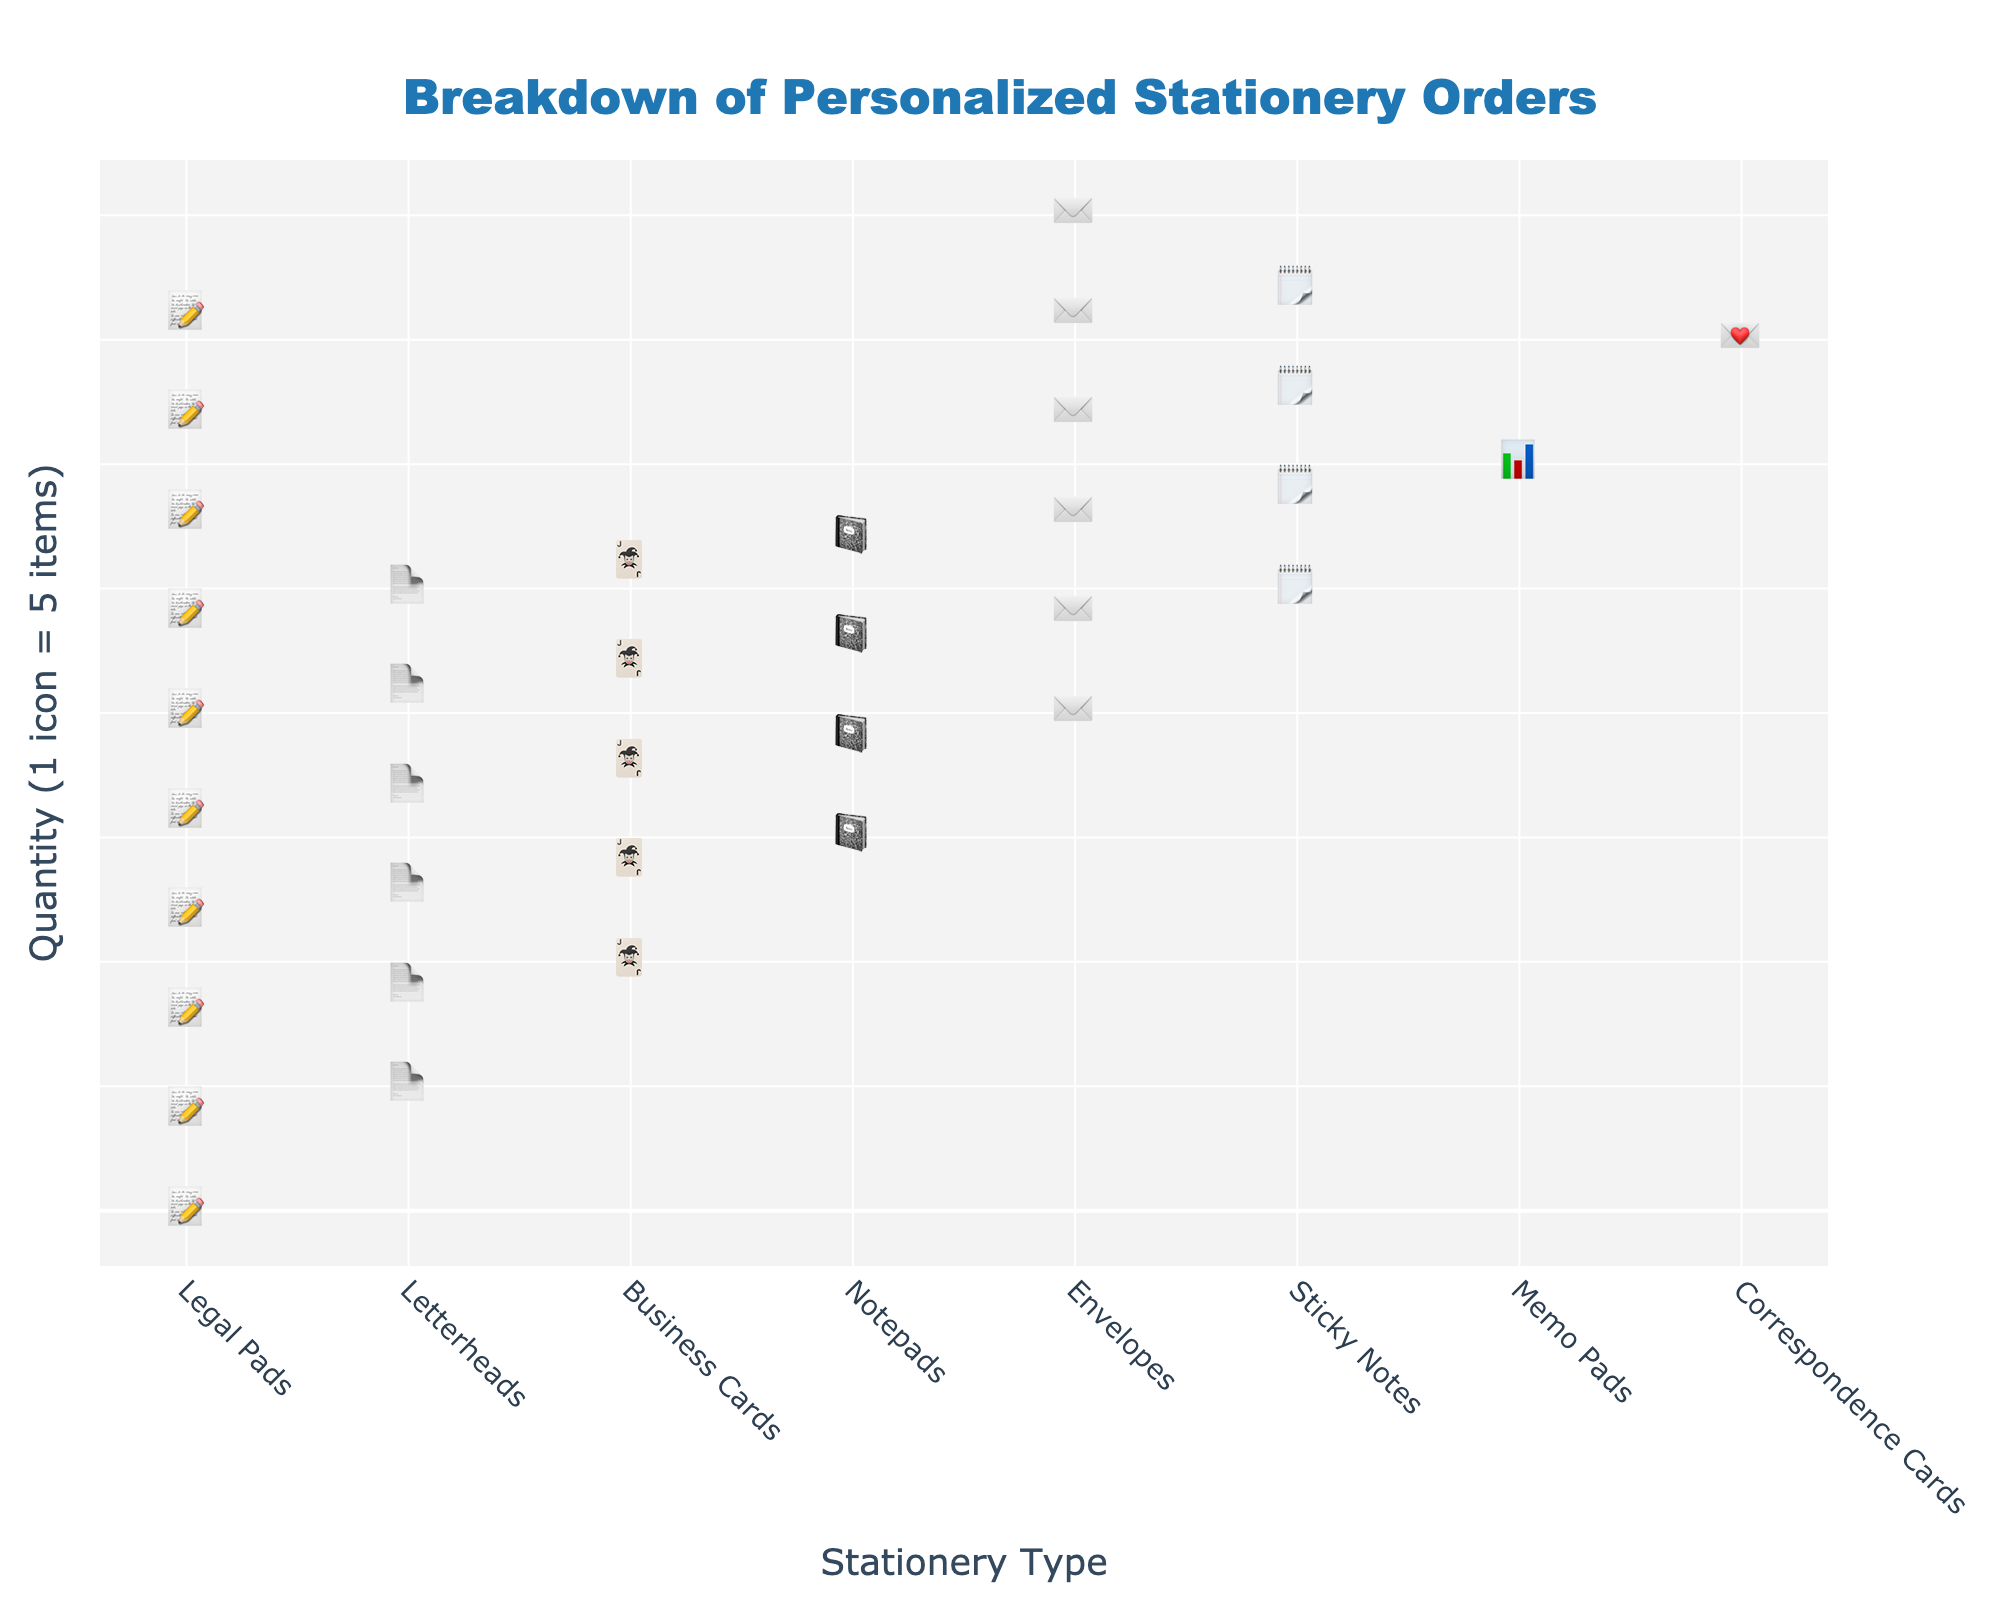What is the title of the figure? The title of the figure is prominently displayed at the top. It reads "Breakdown of Personalized Stationery Orders."
Answer: Breakdown of Personalized Stationery Orders How many types of personalized stationery are represented in the plot? By counting the unique categories on the x-axis, we see 8 types of stationery listed.
Answer: 8 Which type of personalized stationery has the highest number of orders? By looking at the icon quantity for each category, we can see that "Legal Pads" have the most icons, indicating the highest number of orders.
Answer: Legal Pads How many notepads were ordered? Each icon represents 5 items. By counting the icons for notepads, we see 4 icons, so 4 * 5 = 20 notepads.
Answer: 20 What is the difference in orders between Legal Pads and Correspondence Cards? Legal Pads have 50 orders, and Correspondence Cards have 5 orders. The difference is 50 - 5 = 45.
Answer: 45 How do business card orders compare to sticky notes orders? Business Cards have 25 orders while Sticky Notes have 10. Thus, Business Cards have more orders.
Answer: Business Cards have more orders What is the sum of orders for Notepads and Letterheads? Notepads have 20 orders, and Letterheads have 30 orders. Adding them gives 20 + 30 = 50 orders.
Answer: 50 What is the average number of orders for Envelopes and Memo Pads? Envelopes have 15 orders, and Memo Pads have 8 orders. The average is (15 + 8) / 2 = 11.5 orders.
Answer: 11.5 Which type of stationery has exactly 25 orders? By counting the icons, we see that the number of 5 items' icons for Business Cards adds up to 25.
Answer: Business Cards What is the sum of orders for the three least ordered types of stationery? The three least ordered types are Correspondence Cards (5), Memo Pads (8), and Sticky Notes (10). The sum is 5 + 8 + 10 = 23.
Answer: 23 